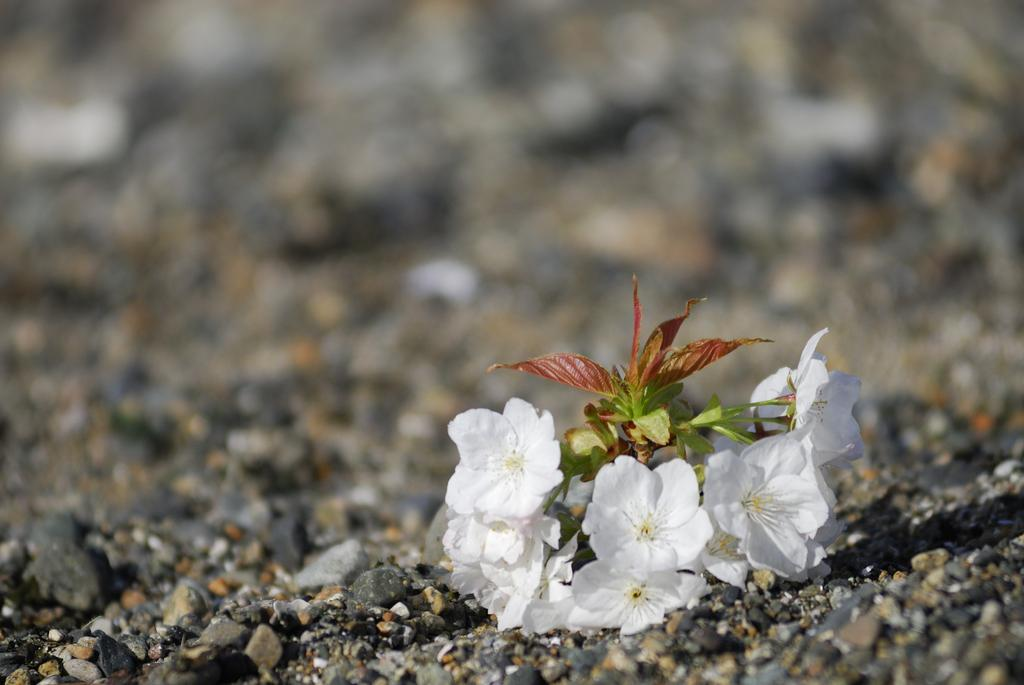What type of flowers can be seen in the image? There are white flowers in the image. What else is present on the ground in the image? There are stones on the ground in the image. Can you describe the background of the image? The background of the image is blurry. What type of hate is being expressed in the image? There is no indication of hate or any negative emotion in the image; it features white flowers and stones on the ground. 